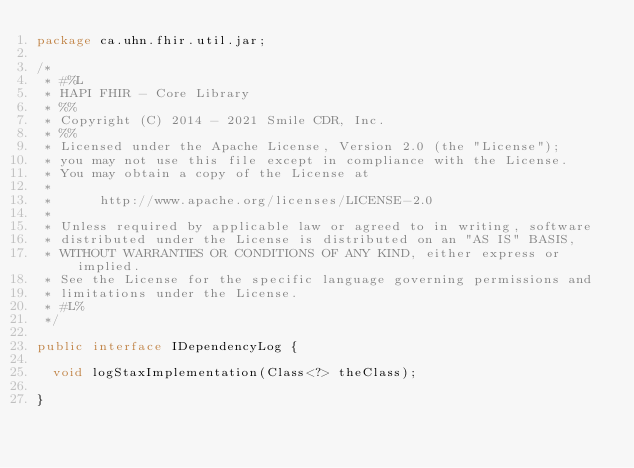<code> <loc_0><loc_0><loc_500><loc_500><_Java_>package ca.uhn.fhir.util.jar;

/*
 * #%L
 * HAPI FHIR - Core Library
 * %%
 * Copyright (C) 2014 - 2021 Smile CDR, Inc.
 * %%
 * Licensed under the Apache License, Version 2.0 (the "License");
 * you may not use this file except in compliance with the License.
 * You may obtain a copy of the License at
 *
 *      http://www.apache.org/licenses/LICENSE-2.0
 *
 * Unless required by applicable law or agreed to in writing, software
 * distributed under the License is distributed on an "AS IS" BASIS,
 * WITHOUT WARRANTIES OR CONDITIONS OF ANY KIND, either express or implied.
 * See the License for the specific language governing permissions and
 * limitations under the License.
 * #L%
 */

public interface IDependencyLog {

	void logStaxImplementation(Class<?> theClass);

}
</code> 